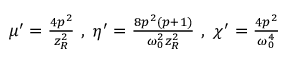<formula> <loc_0><loc_0><loc_500><loc_500>\begin{array} { r } { \mu ^ { \prime } = \frac { 4 p ^ { 2 } } { z _ { R } ^ { 2 } } \ , \ \eta ^ { \prime } = \frac { 8 p ^ { 2 } ( p + 1 ) } { \omega _ { 0 } ^ { 2 } z _ { R } ^ { 2 } } \ , \ \chi ^ { \prime } = \frac { 4 p ^ { 2 } } { \omega _ { 0 } ^ { 4 } } } \end{array}</formula> 